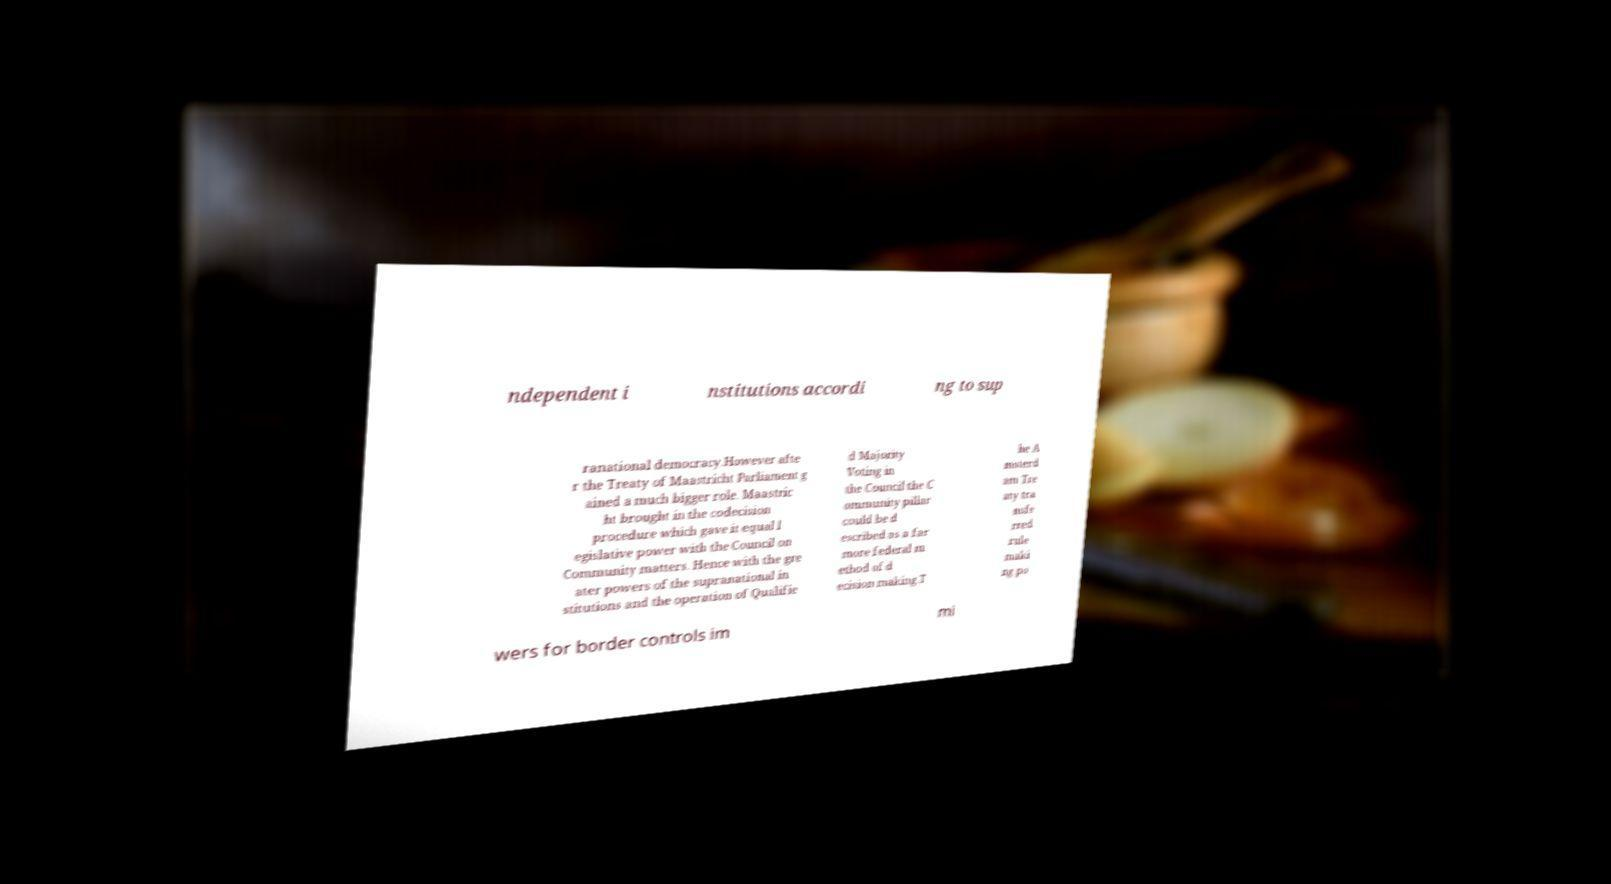Can you read and provide the text displayed in the image?This photo seems to have some interesting text. Can you extract and type it out for me? ndependent i nstitutions accordi ng to sup ranational democracy.However afte r the Treaty of Maastricht Parliament g ained a much bigger role. Maastric ht brought in the codecision procedure which gave it equal l egislative power with the Council on Community matters. Hence with the gre ater powers of the supranational in stitutions and the operation of Qualifie d Majority Voting in the Council the C ommunity pillar could be d escribed as a far more federal m ethod of d ecision making.T he A msterd am Tre aty tra nsfe rred rule maki ng po wers for border controls im mi 